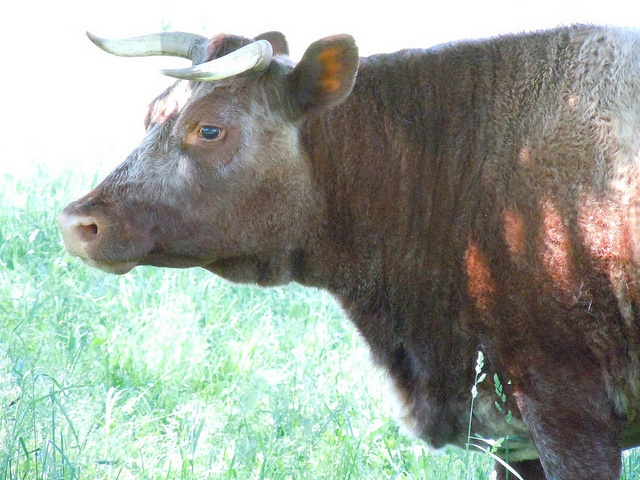Describe the objects in this image and their specific colors. I can see a cow in white, gray, and black tones in this image. 